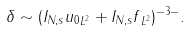<formula> <loc_0><loc_0><loc_500><loc_500>\delta \sim ( \| I _ { N , s } u _ { 0 } \| _ { L ^ { 2 } } + \| I _ { N , s } f \| _ { L ^ { 2 } } ) ^ { - 3 - } .</formula> 